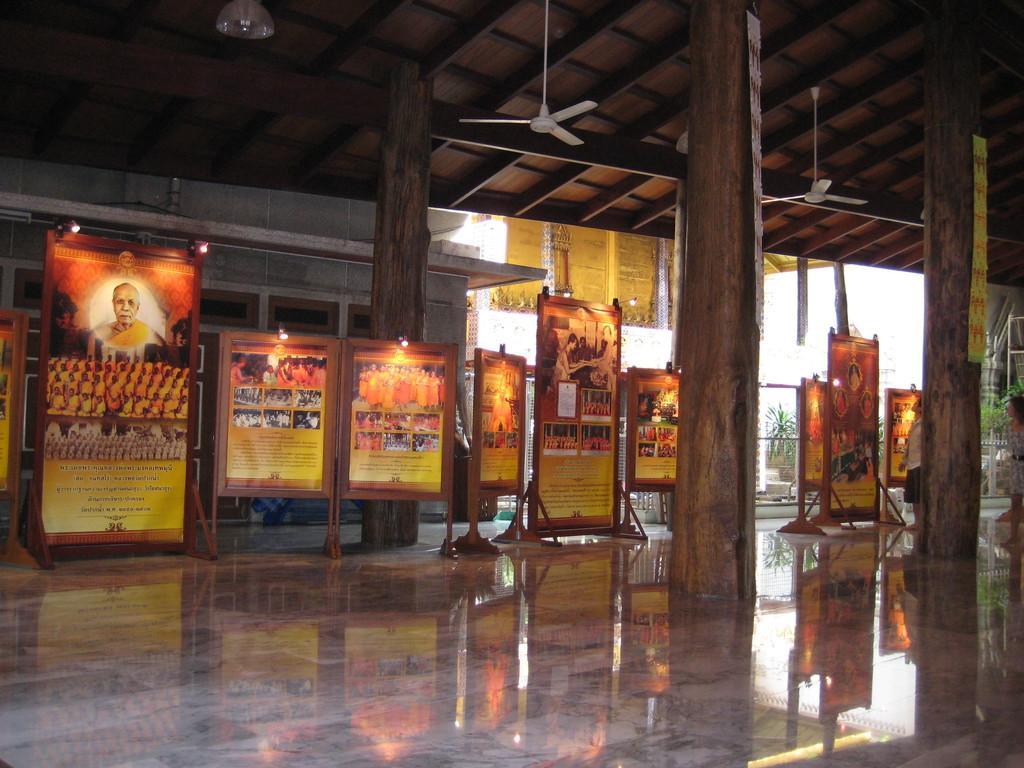Can you describe this image briefly? In this image I see number of boards on which there are pictures of persons and I see something is written and I see the floor and I see the pillars. In the background I see the fans on the ceiling and I see the wall and I see the lights on the boards. 